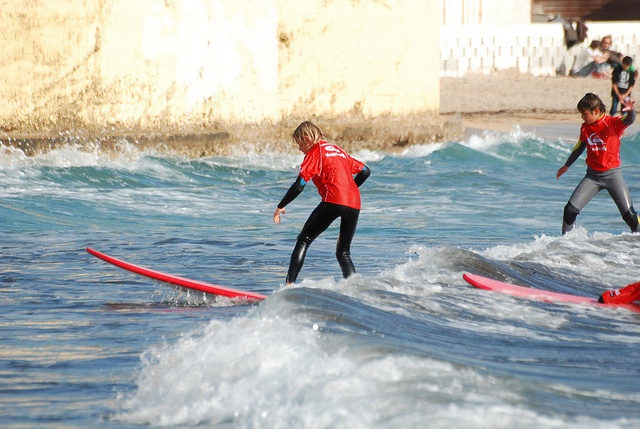Describe the objects in this image and their specific colors. I can see people in lightyellow, black, red, salmon, and brown tones, people in lightyellow, black, gray, and maroon tones, surfboard in lightyellow, red, lightpink, darkgray, and gray tones, surfboard in lightyellow, lightpink, darkgray, lightgray, and gray tones, and people in lightyellow, gray, tan, darkgray, and lightgray tones in this image. 